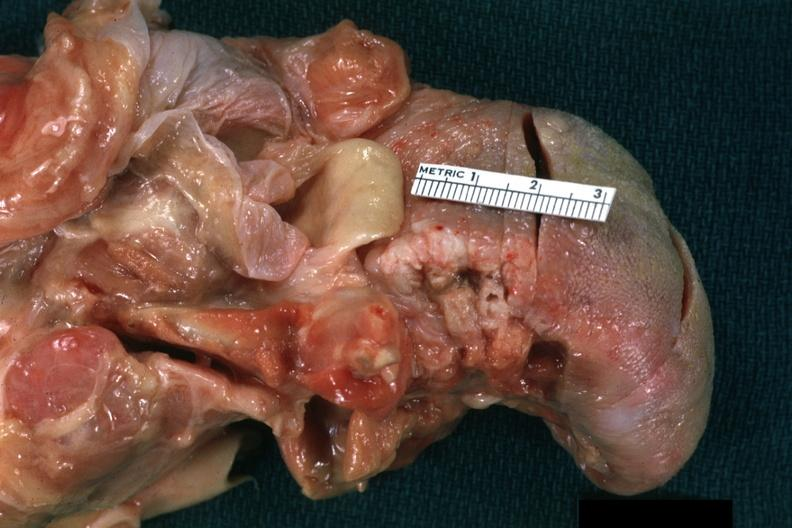s tongue present?
Answer the question using a single word or phrase. Yes 